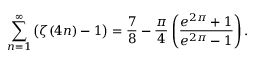Convert formula to latex. <formula><loc_0><loc_0><loc_500><loc_500>\sum _ { n = 1 } ^ { \infty } { \left ( } \zeta ( 4 n ) - 1 { \right ) } = { \frac { 7 } { 8 } } - { \frac { \pi } { 4 } } \left ( { \frac { e ^ { 2 \pi } + 1 } { e ^ { 2 \pi } - 1 } } \right ) .</formula> 